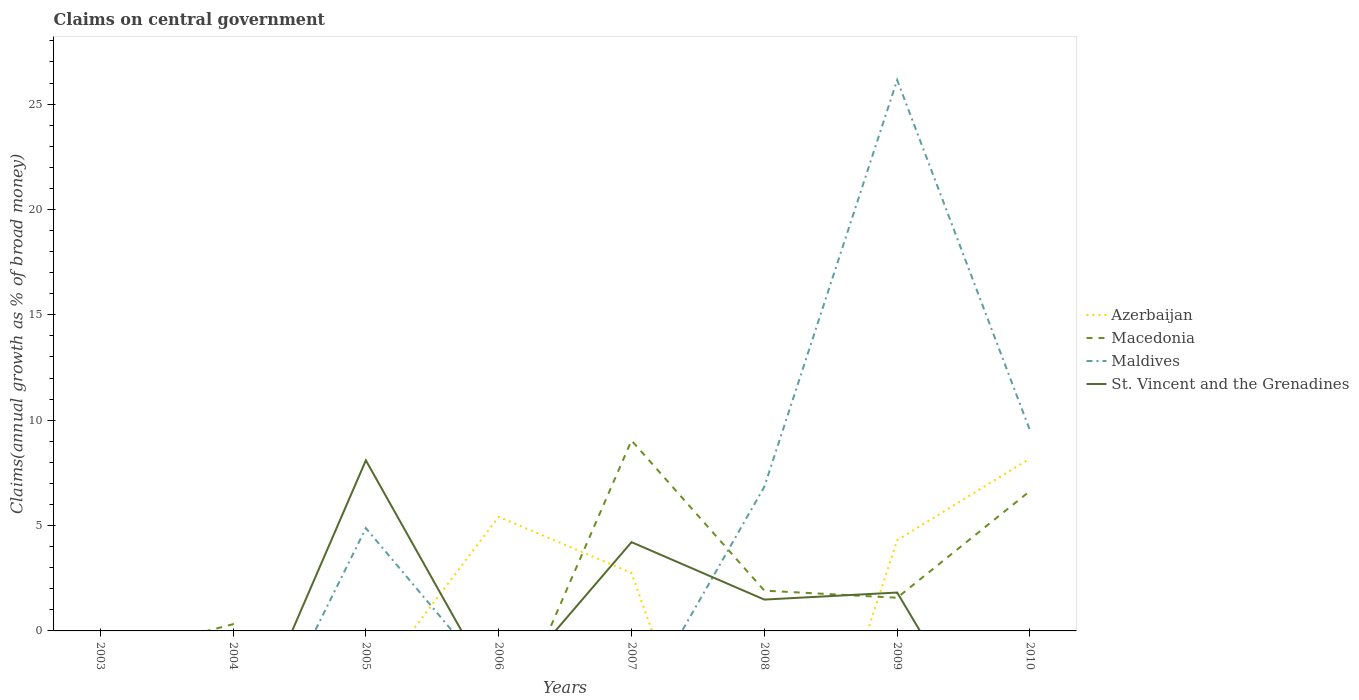What is the total percentage of broad money claimed on centeral government in Azerbaijan in the graph?
Offer a very short reply. 1.11. What is the difference between the highest and the second highest percentage of broad money claimed on centeral government in Macedonia?
Offer a terse response. 9.04. What is the difference between two consecutive major ticks on the Y-axis?
Ensure brevity in your answer.  5. Does the graph contain any zero values?
Your answer should be compact. Yes. Does the graph contain grids?
Make the answer very short. No. What is the title of the graph?
Your answer should be very brief. Claims on central government. Does "Iran" appear as one of the legend labels in the graph?
Your response must be concise. No. What is the label or title of the X-axis?
Offer a very short reply. Years. What is the label or title of the Y-axis?
Offer a terse response. Claims(annual growth as % of broad money). What is the Claims(annual growth as % of broad money) in Azerbaijan in 2003?
Ensure brevity in your answer.  0. What is the Claims(annual growth as % of broad money) in Macedonia in 2003?
Make the answer very short. 0. What is the Claims(annual growth as % of broad money) of Maldives in 2003?
Your response must be concise. 0. What is the Claims(annual growth as % of broad money) in Macedonia in 2004?
Provide a short and direct response. 0.32. What is the Claims(annual growth as % of broad money) of St. Vincent and the Grenadines in 2004?
Give a very brief answer. 0. What is the Claims(annual growth as % of broad money) of Azerbaijan in 2005?
Your answer should be compact. 0. What is the Claims(annual growth as % of broad money) in Macedonia in 2005?
Make the answer very short. 0. What is the Claims(annual growth as % of broad money) in Maldives in 2005?
Give a very brief answer. 4.88. What is the Claims(annual growth as % of broad money) in St. Vincent and the Grenadines in 2005?
Ensure brevity in your answer.  8.1. What is the Claims(annual growth as % of broad money) in Azerbaijan in 2006?
Give a very brief answer. 5.42. What is the Claims(annual growth as % of broad money) in Azerbaijan in 2007?
Make the answer very short. 2.75. What is the Claims(annual growth as % of broad money) in Macedonia in 2007?
Keep it short and to the point. 9.04. What is the Claims(annual growth as % of broad money) of Maldives in 2007?
Give a very brief answer. 0. What is the Claims(annual growth as % of broad money) in St. Vincent and the Grenadines in 2007?
Your response must be concise. 4.21. What is the Claims(annual growth as % of broad money) in Macedonia in 2008?
Offer a terse response. 1.91. What is the Claims(annual growth as % of broad money) in Maldives in 2008?
Your answer should be compact. 6.84. What is the Claims(annual growth as % of broad money) in St. Vincent and the Grenadines in 2008?
Offer a very short reply. 1.49. What is the Claims(annual growth as % of broad money) of Azerbaijan in 2009?
Your answer should be compact. 4.31. What is the Claims(annual growth as % of broad money) of Macedonia in 2009?
Provide a succinct answer. 1.57. What is the Claims(annual growth as % of broad money) in Maldives in 2009?
Provide a short and direct response. 26.15. What is the Claims(annual growth as % of broad money) of St. Vincent and the Grenadines in 2009?
Offer a terse response. 1.82. What is the Claims(annual growth as % of broad money) of Azerbaijan in 2010?
Give a very brief answer. 8.19. What is the Claims(annual growth as % of broad money) in Macedonia in 2010?
Provide a short and direct response. 6.64. What is the Claims(annual growth as % of broad money) of Maldives in 2010?
Give a very brief answer. 9.51. Across all years, what is the maximum Claims(annual growth as % of broad money) in Azerbaijan?
Provide a succinct answer. 8.19. Across all years, what is the maximum Claims(annual growth as % of broad money) of Macedonia?
Your answer should be very brief. 9.04. Across all years, what is the maximum Claims(annual growth as % of broad money) in Maldives?
Provide a succinct answer. 26.15. Across all years, what is the maximum Claims(annual growth as % of broad money) of St. Vincent and the Grenadines?
Provide a succinct answer. 8.1. Across all years, what is the minimum Claims(annual growth as % of broad money) of Macedonia?
Offer a very short reply. 0. Across all years, what is the minimum Claims(annual growth as % of broad money) of Maldives?
Make the answer very short. 0. Across all years, what is the minimum Claims(annual growth as % of broad money) in St. Vincent and the Grenadines?
Your answer should be very brief. 0. What is the total Claims(annual growth as % of broad money) of Azerbaijan in the graph?
Ensure brevity in your answer.  20.66. What is the total Claims(annual growth as % of broad money) in Macedonia in the graph?
Offer a very short reply. 19.48. What is the total Claims(annual growth as % of broad money) of Maldives in the graph?
Provide a short and direct response. 47.38. What is the total Claims(annual growth as % of broad money) of St. Vincent and the Grenadines in the graph?
Provide a succinct answer. 15.62. What is the difference between the Claims(annual growth as % of broad money) of Macedonia in 2004 and that in 2007?
Keep it short and to the point. -8.72. What is the difference between the Claims(annual growth as % of broad money) of Macedonia in 2004 and that in 2008?
Provide a succinct answer. -1.59. What is the difference between the Claims(annual growth as % of broad money) of Macedonia in 2004 and that in 2009?
Your answer should be very brief. -1.25. What is the difference between the Claims(annual growth as % of broad money) of Macedonia in 2004 and that in 2010?
Offer a very short reply. -6.32. What is the difference between the Claims(annual growth as % of broad money) of St. Vincent and the Grenadines in 2005 and that in 2007?
Offer a terse response. 3.88. What is the difference between the Claims(annual growth as % of broad money) of Maldives in 2005 and that in 2008?
Offer a terse response. -1.96. What is the difference between the Claims(annual growth as % of broad money) in St. Vincent and the Grenadines in 2005 and that in 2008?
Offer a very short reply. 6.61. What is the difference between the Claims(annual growth as % of broad money) of Maldives in 2005 and that in 2009?
Your response must be concise. -21.27. What is the difference between the Claims(annual growth as % of broad money) in St. Vincent and the Grenadines in 2005 and that in 2009?
Your response must be concise. 6.27. What is the difference between the Claims(annual growth as % of broad money) in Maldives in 2005 and that in 2010?
Your answer should be compact. -4.63. What is the difference between the Claims(annual growth as % of broad money) of Azerbaijan in 2006 and that in 2007?
Your answer should be compact. 2.66. What is the difference between the Claims(annual growth as % of broad money) in Azerbaijan in 2006 and that in 2009?
Provide a short and direct response. 1.11. What is the difference between the Claims(annual growth as % of broad money) in Azerbaijan in 2006 and that in 2010?
Your response must be concise. -2.77. What is the difference between the Claims(annual growth as % of broad money) of Macedonia in 2007 and that in 2008?
Ensure brevity in your answer.  7.13. What is the difference between the Claims(annual growth as % of broad money) of St. Vincent and the Grenadines in 2007 and that in 2008?
Keep it short and to the point. 2.73. What is the difference between the Claims(annual growth as % of broad money) in Azerbaijan in 2007 and that in 2009?
Make the answer very short. -1.55. What is the difference between the Claims(annual growth as % of broad money) of Macedonia in 2007 and that in 2009?
Your response must be concise. 7.46. What is the difference between the Claims(annual growth as % of broad money) in St. Vincent and the Grenadines in 2007 and that in 2009?
Make the answer very short. 2.39. What is the difference between the Claims(annual growth as % of broad money) in Azerbaijan in 2007 and that in 2010?
Keep it short and to the point. -5.43. What is the difference between the Claims(annual growth as % of broad money) in Macedonia in 2007 and that in 2010?
Offer a terse response. 2.4. What is the difference between the Claims(annual growth as % of broad money) in Macedonia in 2008 and that in 2009?
Keep it short and to the point. 0.34. What is the difference between the Claims(annual growth as % of broad money) in Maldives in 2008 and that in 2009?
Your answer should be compact. -19.3. What is the difference between the Claims(annual growth as % of broad money) in St. Vincent and the Grenadines in 2008 and that in 2009?
Provide a succinct answer. -0.33. What is the difference between the Claims(annual growth as % of broad money) of Macedonia in 2008 and that in 2010?
Give a very brief answer. -4.73. What is the difference between the Claims(annual growth as % of broad money) in Maldives in 2008 and that in 2010?
Your response must be concise. -2.67. What is the difference between the Claims(annual growth as % of broad money) in Azerbaijan in 2009 and that in 2010?
Provide a short and direct response. -3.88. What is the difference between the Claims(annual growth as % of broad money) in Macedonia in 2009 and that in 2010?
Offer a terse response. -5.07. What is the difference between the Claims(annual growth as % of broad money) of Maldives in 2009 and that in 2010?
Keep it short and to the point. 16.63. What is the difference between the Claims(annual growth as % of broad money) in Macedonia in 2004 and the Claims(annual growth as % of broad money) in Maldives in 2005?
Your response must be concise. -4.56. What is the difference between the Claims(annual growth as % of broad money) in Macedonia in 2004 and the Claims(annual growth as % of broad money) in St. Vincent and the Grenadines in 2005?
Offer a terse response. -7.78. What is the difference between the Claims(annual growth as % of broad money) of Macedonia in 2004 and the Claims(annual growth as % of broad money) of St. Vincent and the Grenadines in 2007?
Give a very brief answer. -3.89. What is the difference between the Claims(annual growth as % of broad money) of Macedonia in 2004 and the Claims(annual growth as % of broad money) of Maldives in 2008?
Your answer should be compact. -6.52. What is the difference between the Claims(annual growth as % of broad money) in Macedonia in 2004 and the Claims(annual growth as % of broad money) in St. Vincent and the Grenadines in 2008?
Your answer should be very brief. -1.17. What is the difference between the Claims(annual growth as % of broad money) of Macedonia in 2004 and the Claims(annual growth as % of broad money) of Maldives in 2009?
Offer a very short reply. -25.83. What is the difference between the Claims(annual growth as % of broad money) in Macedonia in 2004 and the Claims(annual growth as % of broad money) in St. Vincent and the Grenadines in 2009?
Make the answer very short. -1.5. What is the difference between the Claims(annual growth as % of broad money) in Macedonia in 2004 and the Claims(annual growth as % of broad money) in Maldives in 2010?
Your answer should be very brief. -9.19. What is the difference between the Claims(annual growth as % of broad money) in Maldives in 2005 and the Claims(annual growth as % of broad money) in St. Vincent and the Grenadines in 2007?
Your response must be concise. 0.67. What is the difference between the Claims(annual growth as % of broad money) of Maldives in 2005 and the Claims(annual growth as % of broad money) of St. Vincent and the Grenadines in 2008?
Offer a terse response. 3.39. What is the difference between the Claims(annual growth as % of broad money) of Maldives in 2005 and the Claims(annual growth as % of broad money) of St. Vincent and the Grenadines in 2009?
Ensure brevity in your answer.  3.06. What is the difference between the Claims(annual growth as % of broad money) in Azerbaijan in 2006 and the Claims(annual growth as % of broad money) in Macedonia in 2007?
Make the answer very short. -3.62. What is the difference between the Claims(annual growth as % of broad money) in Azerbaijan in 2006 and the Claims(annual growth as % of broad money) in St. Vincent and the Grenadines in 2007?
Provide a short and direct response. 1.2. What is the difference between the Claims(annual growth as % of broad money) in Azerbaijan in 2006 and the Claims(annual growth as % of broad money) in Macedonia in 2008?
Ensure brevity in your answer.  3.5. What is the difference between the Claims(annual growth as % of broad money) of Azerbaijan in 2006 and the Claims(annual growth as % of broad money) of Maldives in 2008?
Ensure brevity in your answer.  -1.43. What is the difference between the Claims(annual growth as % of broad money) of Azerbaijan in 2006 and the Claims(annual growth as % of broad money) of St. Vincent and the Grenadines in 2008?
Your response must be concise. 3.93. What is the difference between the Claims(annual growth as % of broad money) in Azerbaijan in 2006 and the Claims(annual growth as % of broad money) in Macedonia in 2009?
Offer a very short reply. 3.84. What is the difference between the Claims(annual growth as % of broad money) in Azerbaijan in 2006 and the Claims(annual growth as % of broad money) in Maldives in 2009?
Make the answer very short. -20.73. What is the difference between the Claims(annual growth as % of broad money) of Azerbaijan in 2006 and the Claims(annual growth as % of broad money) of St. Vincent and the Grenadines in 2009?
Your answer should be compact. 3.59. What is the difference between the Claims(annual growth as % of broad money) in Azerbaijan in 2006 and the Claims(annual growth as % of broad money) in Macedonia in 2010?
Give a very brief answer. -1.22. What is the difference between the Claims(annual growth as % of broad money) of Azerbaijan in 2006 and the Claims(annual growth as % of broad money) of Maldives in 2010?
Your answer should be compact. -4.1. What is the difference between the Claims(annual growth as % of broad money) of Azerbaijan in 2007 and the Claims(annual growth as % of broad money) of Macedonia in 2008?
Keep it short and to the point. 0.84. What is the difference between the Claims(annual growth as % of broad money) of Azerbaijan in 2007 and the Claims(annual growth as % of broad money) of Maldives in 2008?
Offer a terse response. -4.09. What is the difference between the Claims(annual growth as % of broad money) in Azerbaijan in 2007 and the Claims(annual growth as % of broad money) in St. Vincent and the Grenadines in 2008?
Ensure brevity in your answer.  1.26. What is the difference between the Claims(annual growth as % of broad money) of Macedonia in 2007 and the Claims(annual growth as % of broad money) of Maldives in 2008?
Make the answer very short. 2.2. What is the difference between the Claims(annual growth as % of broad money) in Macedonia in 2007 and the Claims(annual growth as % of broad money) in St. Vincent and the Grenadines in 2008?
Your answer should be compact. 7.55. What is the difference between the Claims(annual growth as % of broad money) in Azerbaijan in 2007 and the Claims(annual growth as % of broad money) in Macedonia in 2009?
Offer a terse response. 1.18. What is the difference between the Claims(annual growth as % of broad money) of Azerbaijan in 2007 and the Claims(annual growth as % of broad money) of Maldives in 2009?
Make the answer very short. -23.39. What is the difference between the Claims(annual growth as % of broad money) in Azerbaijan in 2007 and the Claims(annual growth as % of broad money) in St. Vincent and the Grenadines in 2009?
Provide a succinct answer. 0.93. What is the difference between the Claims(annual growth as % of broad money) in Macedonia in 2007 and the Claims(annual growth as % of broad money) in Maldives in 2009?
Your response must be concise. -17.11. What is the difference between the Claims(annual growth as % of broad money) of Macedonia in 2007 and the Claims(annual growth as % of broad money) of St. Vincent and the Grenadines in 2009?
Give a very brief answer. 7.22. What is the difference between the Claims(annual growth as % of broad money) in Azerbaijan in 2007 and the Claims(annual growth as % of broad money) in Macedonia in 2010?
Ensure brevity in your answer.  -3.89. What is the difference between the Claims(annual growth as % of broad money) of Azerbaijan in 2007 and the Claims(annual growth as % of broad money) of Maldives in 2010?
Provide a short and direct response. -6.76. What is the difference between the Claims(annual growth as % of broad money) in Macedonia in 2007 and the Claims(annual growth as % of broad money) in Maldives in 2010?
Offer a very short reply. -0.47. What is the difference between the Claims(annual growth as % of broad money) of Macedonia in 2008 and the Claims(annual growth as % of broad money) of Maldives in 2009?
Give a very brief answer. -24.23. What is the difference between the Claims(annual growth as % of broad money) of Macedonia in 2008 and the Claims(annual growth as % of broad money) of St. Vincent and the Grenadines in 2009?
Provide a short and direct response. 0.09. What is the difference between the Claims(annual growth as % of broad money) of Maldives in 2008 and the Claims(annual growth as % of broad money) of St. Vincent and the Grenadines in 2009?
Provide a short and direct response. 5.02. What is the difference between the Claims(annual growth as % of broad money) in Macedonia in 2008 and the Claims(annual growth as % of broad money) in Maldives in 2010?
Provide a succinct answer. -7.6. What is the difference between the Claims(annual growth as % of broad money) in Azerbaijan in 2009 and the Claims(annual growth as % of broad money) in Macedonia in 2010?
Ensure brevity in your answer.  -2.33. What is the difference between the Claims(annual growth as % of broad money) in Azerbaijan in 2009 and the Claims(annual growth as % of broad money) in Maldives in 2010?
Keep it short and to the point. -5.21. What is the difference between the Claims(annual growth as % of broad money) of Macedonia in 2009 and the Claims(annual growth as % of broad money) of Maldives in 2010?
Offer a terse response. -7.94. What is the average Claims(annual growth as % of broad money) in Azerbaijan per year?
Provide a short and direct response. 2.58. What is the average Claims(annual growth as % of broad money) of Macedonia per year?
Offer a terse response. 2.44. What is the average Claims(annual growth as % of broad money) in Maldives per year?
Keep it short and to the point. 5.92. What is the average Claims(annual growth as % of broad money) of St. Vincent and the Grenadines per year?
Offer a terse response. 1.95. In the year 2005, what is the difference between the Claims(annual growth as % of broad money) of Maldives and Claims(annual growth as % of broad money) of St. Vincent and the Grenadines?
Give a very brief answer. -3.22. In the year 2007, what is the difference between the Claims(annual growth as % of broad money) in Azerbaijan and Claims(annual growth as % of broad money) in Macedonia?
Your answer should be compact. -6.29. In the year 2007, what is the difference between the Claims(annual growth as % of broad money) in Azerbaijan and Claims(annual growth as % of broad money) in St. Vincent and the Grenadines?
Provide a succinct answer. -1.46. In the year 2007, what is the difference between the Claims(annual growth as % of broad money) of Macedonia and Claims(annual growth as % of broad money) of St. Vincent and the Grenadines?
Provide a short and direct response. 4.83. In the year 2008, what is the difference between the Claims(annual growth as % of broad money) of Macedonia and Claims(annual growth as % of broad money) of Maldives?
Make the answer very short. -4.93. In the year 2008, what is the difference between the Claims(annual growth as % of broad money) in Macedonia and Claims(annual growth as % of broad money) in St. Vincent and the Grenadines?
Ensure brevity in your answer.  0.43. In the year 2008, what is the difference between the Claims(annual growth as % of broad money) in Maldives and Claims(annual growth as % of broad money) in St. Vincent and the Grenadines?
Provide a succinct answer. 5.35. In the year 2009, what is the difference between the Claims(annual growth as % of broad money) of Azerbaijan and Claims(annual growth as % of broad money) of Macedonia?
Your response must be concise. 2.73. In the year 2009, what is the difference between the Claims(annual growth as % of broad money) of Azerbaijan and Claims(annual growth as % of broad money) of Maldives?
Provide a succinct answer. -21.84. In the year 2009, what is the difference between the Claims(annual growth as % of broad money) in Azerbaijan and Claims(annual growth as % of broad money) in St. Vincent and the Grenadines?
Offer a very short reply. 2.48. In the year 2009, what is the difference between the Claims(annual growth as % of broad money) of Macedonia and Claims(annual growth as % of broad money) of Maldives?
Offer a terse response. -24.57. In the year 2009, what is the difference between the Claims(annual growth as % of broad money) of Macedonia and Claims(annual growth as % of broad money) of St. Vincent and the Grenadines?
Offer a terse response. -0.25. In the year 2009, what is the difference between the Claims(annual growth as % of broad money) in Maldives and Claims(annual growth as % of broad money) in St. Vincent and the Grenadines?
Offer a terse response. 24.32. In the year 2010, what is the difference between the Claims(annual growth as % of broad money) in Azerbaijan and Claims(annual growth as % of broad money) in Macedonia?
Make the answer very short. 1.55. In the year 2010, what is the difference between the Claims(annual growth as % of broad money) of Azerbaijan and Claims(annual growth as % of broad money) of Maldives?
Make the answer very short. -1.33. In the year 2010, what is the difference between the Claims(annual growth as % of broad money) of Macedonia and Claims(annual growth as % of broad money) of Maldives?
Your answer should be very brief. -2.87. What is the ratio of the Claims(annual growth as % of broad money) of Macedonia in 2004 to that in 2007?
Keep it short and to the point. 0.04. What is the ratio of the Claims(annual growth as % of broad money) of Macedonia in 2004 to that in 2008?
Your response must be concise. 0.17. What is the ratio of the Claims(annual growth as % of broad money) in Macedonia in 2004 to that in 2009?
Keep it short and to the point. 0.2. What is the ratio of the Claims(annual growth as % of broad money) in Macedonia in 2004 to that in 2010?
Keep it short and to the point. 0.05. What is the ratio of the Claims(annual growth as % of broad money) of St. Vincent and the Grenadines in 2005 to that in 2007?
Your answer should be compact. 1.92. What is the ratio of the Claims(annual growth as % of broad money) in Maldives in 2005 to that in 2008?
Provide a succinct answer. 0.71. What is the ratio of the Claims(annual growth as % of broad money) in St. Vincent and the Grenadines in 2005 to that in 2008?
Give a very brief answer. 5.44. What is the ratio of the Claims(annual growth as % of broad money) in Maldives in 2005 to that in 2009?
Your answer should be compact. 0.19. What is the ratio of the Claims(annual growth as % of broad money) in St. Vincent and the Grenadines in 2005 to that in 2009?
Provide a short and direct response. 4.44. What is the ratio of the Claims(annual growth as % of broad money) in Maldives in 2005 to that in 2010?
Your response must be concise. 0.51. What is the ratio of the Claims(annual growth as % of broad money) of Azerbaijan in 2006 to that in 2007?
Keep it short and to the point. 1.97. What is the ratio of the Claims(annual growth as % of broad money) in Azerbaijan in 2006 to that in 2009?
Your response must be concise. 1.26. What is the ratio of the Claims(annual growth as % of broad money) of Azerbaijan in 2006 to that in 2010?
Give a very brief answer. 0.66. What is the ratio of the Claims(annual growth as % of broad money) in Macedonia in 2007 to that in 2008?
Give a very brief answer. 4.73. What is the ratio of the Claims(annual growth as % of broad money) in St. Vincent and the Grenadines in 2007 to that in 2008?
Your response must be concise. 2.83. What is the ratio of the Claims(annual growth as % of broad money) in Azerbaijan in 2007 to that in 2009?
Offer a terse response. 0.64. What is the ratio of the Claims(annual growth as % of broad money) in Macedonia in 2007 to that in 2009?
Offer a very short reply. 5.74. What is the ratio of the Claims(annual growth as % of broad money) of St. Vincent and the Grenadines in 2007 to that in 2009?
Make the answer very short. 2.31. What is the ratio of the Claims(annual growth as % of broad money) of Azerbaijan in 2007 to that in 2010?
Your answer should be compact. 0.34. What is the ratio of the Claims(annual growth as % of broad money) in Macedonia in 2007 to that in 2010?
Offer a very short reply. 1.36. What is the ratio of the Claims(annual growth as % of broad money) in Macedonia in 2008 to that in 2009?
Keep it short and to the point. 1.22. What is the ratio of the Claims(annual growth as % of broad money) of Maldives in 2008 to that in 2009?
Your response must be concise. 0.26. What is the ratio of the Claims(annual growth as % of broad money) of St. Vincent and the Grenadines in 2008 to that in 2009?
Make the answer very short. 0.82. What is the ratio of the Claims(annual growth as % of broad money) in Macedonia in 2008 to that in 2010?
Give a very brief answer. 0.29. What is the ratio of the Claims(annual growth as % of broad money) of Maldives in 2008 to that in 2010?
Make the answer very short. 0.72. What is the ratio of the Claims(annual growth as % of broad money) in Azerbaijan in 2009 to that in 2010?
Provide a short and direct response. 0.53. What is the ratio of the Claims(annual growth as % of broad money) in Macedonia in 2009 to that in 2010?
Keep it short and to the point. 0.24. What is the ratio of the Claims(annual growth as % of broad money) in Maldives in 2009 to that in 2010?
Offer a very short reply. 2.75. What is the difference between the highest and the second highest Claims(annual growth as % of broad money) of Azerbaijan?
Keep it short and to the point. 2.77. What is the difference between the highest and the second highest Claims(annual growth as % of broad money) of Macedonia?
Your answer should be compact. 2.4. What is the difference between the highest and the second highest Claims(annual growth as % of broad money) in Maldives?
Offer a very short reply. 16.63. What is the difference between the highest and the second highest Claims(annual growth as % of broad money) of St. Vincent and the Grenadines?
Your response must be concise. 3.88. What is the difference between the highest and the lowest Claims(annual growth as % of broad money) in Azerbaijan?
Provide a short and direct response. 8.19. What is the difference between the highest and the lowest Claims(annual growth as % of broad money) in Macedonia?
Provide a short and direct response. 9.04. What is the difference between the highest and the lowest Claims(annual growth as % of broad money) in Maldives?
Ensure brevity in your answer.  26.15. What is the difference between the highest and the lowest Claims(annual growth as % of broad money) of St. Vincent and the Grenadines?
Offer a terse response. 8.1. 